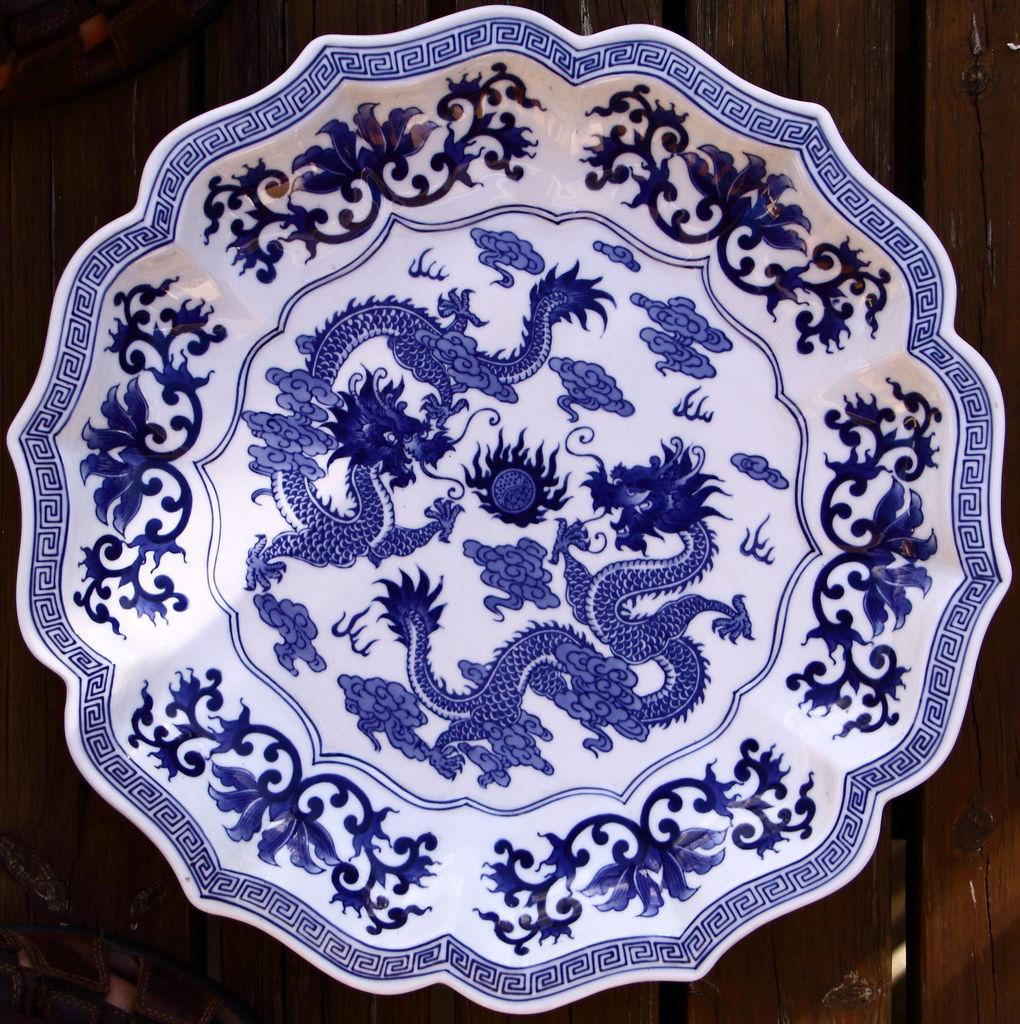What is present on the wooden surface in the image? There is a bowl in the image. Can you describe the wooden surface in the image? The wooden surface is not described in the provided facts. What design is featured on the bowl in the image? The bowl has a design of flowers and snakes. What type of screw is being used to hold the light fixture in the image? There is no light fixture or screw present in the image; it only features a bowl with a design of flowers and snakes on a wooden surface. What role does the minister play in the image? There is no minister present in the image; it only features a bowl with a design of flowers and snakes on a wooden surface. 